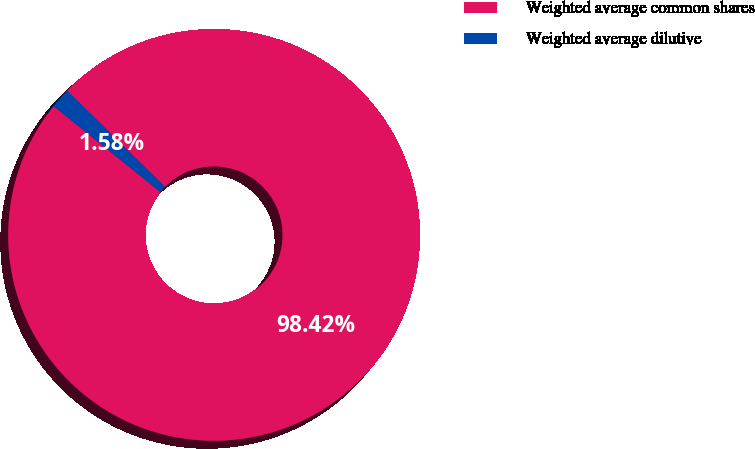Convert chart to OTSL. <chart><loc_0><loc_0><loc_500><loc_500><pie_chart><fcel>Weighted average common shares<fcel>Weighted average dilutive<nl><fcel>98.42%<fcel>1.58%<nl></chart> 